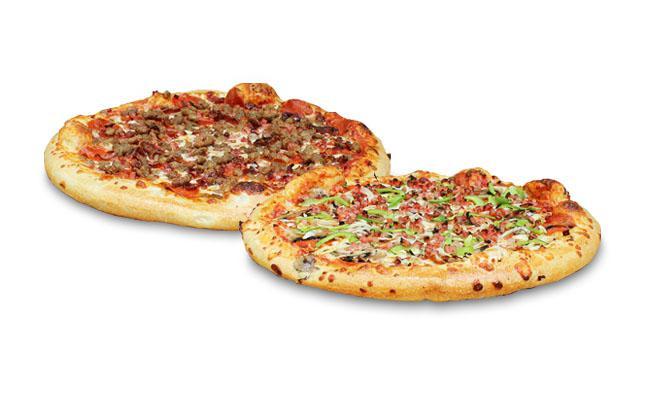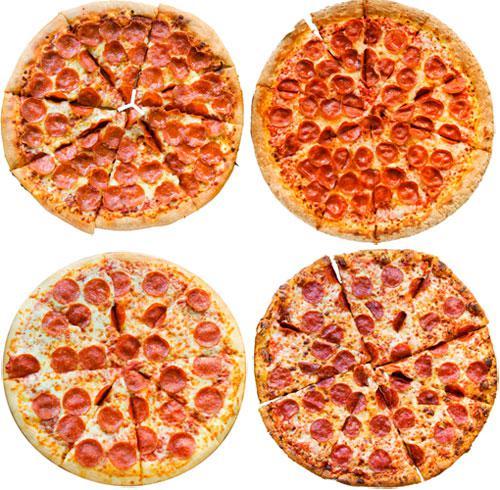The first image is the image on the left, the second image is the image on the right. Considering the images on both sides, is "At least 2 pizzas have pepperoni on them in one of the pictures." valid? Answer yes or no. Yes. 